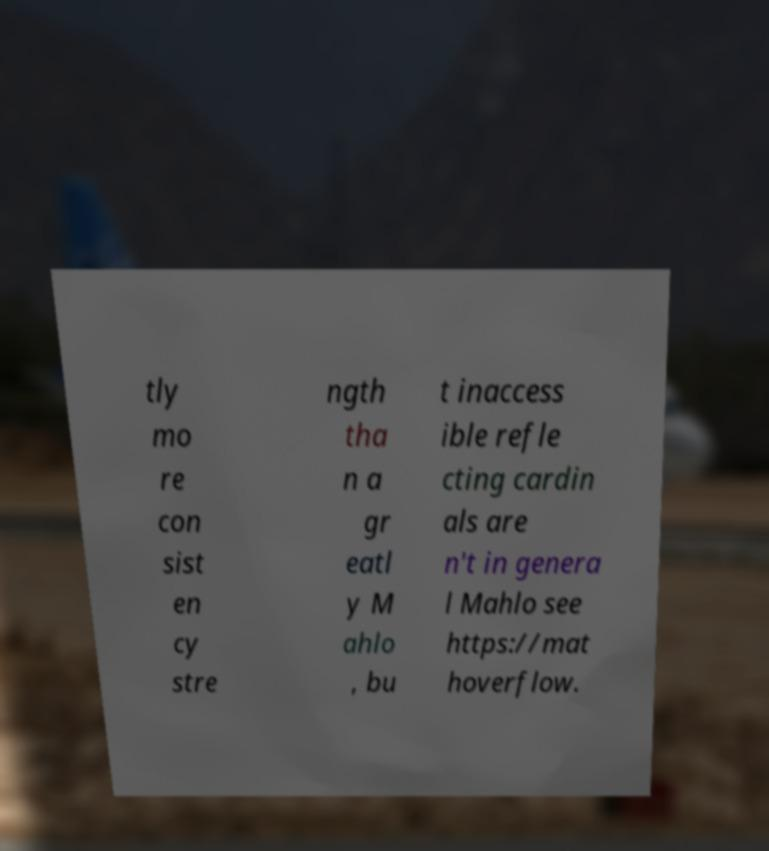Could you extract and type out the text from this image? tly mo re con sist en cy stre ngth tha n a gr eatl y M ahlo , bu t inaccess ible refle cting cardin als are n't in genera l Mahlo see https://mat hoverflow. 